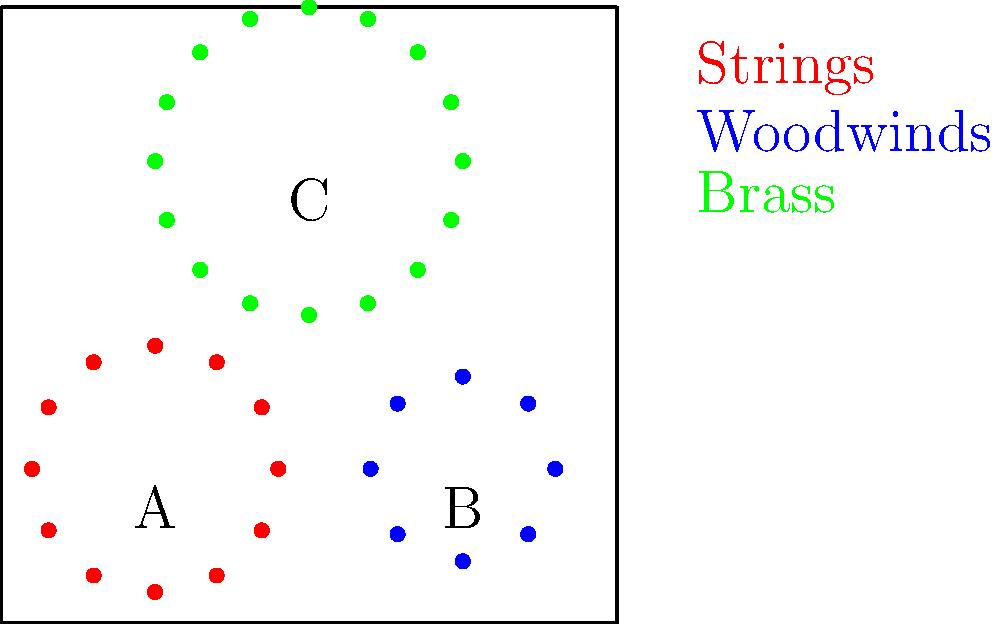As a music critic, analyze the seating arrangement of the three orchestras (A, B, and C) shown in the diagram. Which orchestra layout would likely produce the most balanced sound across all instrument groups, and why? To answer this question, let's analyze each orchestra layout:

1. Orchestra A (red):
   - Larger circle with 12 seats
   - Likely represents string instruments
   - Positioned at the front left of the stage

2. Orchestra B (blue):
   - Smaller circle with 8 seats
   - Likely represents woodwind instruments
   - Positioned at the front right of the stage

3. Orchestra C (green):
   - Largest circle with 16 seats
   - Likely represents brass instruments
   - Positioned at the back center of the stage

Now, let's consider the factors that contribute to a balanced sound:

1. Instrument group placement: In a balanced arrangement, no single group should overpower the others.
2. Sound projection: Different instrument groups have varying levels of sound projection.
3. Stage coverage: A well-distributed arrangement allows for better blending of sounds.

Analyzing the layouts:

- Orchestra C (green) has the most balanced arrangement:
  a. It's centrally located, allowing sound to project evenly across the stage.
  b. The larger circle suggests more space between musicians, which can help with sound blending.
  c. Being at the back allows other instrument groups to be heard clearly.

- Orchestra A and B (red and blue) are positioned at the front, which might overpower Orchestra C if not carefully balanced.

- The separation between A and B allows for some stereo effect, but might lead to an imbalance if not properly coordinated.

Given these factors, Orchestra C's layout is likely to produce the most balanced sound across all instrument groups. Its central position and larger spacing allow for better sound blending and prevent any single group from dominating the overall sound.
Answer: Orchestra C 